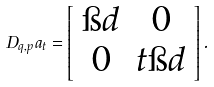<formula> <loc_0><loc_0><loc_500><loc_500>D _ { q , p } a _ { t } = \left [ \begin{array} { c c } \i d & 0 \\ 0 & t \i d \end{array} \right ] .</formula> 